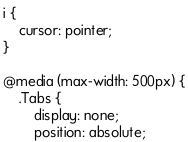Convert code to text. <code><loc_0><loc_0><loc_500><loc_500><_CSS_>
i {
    cursor: pointer;
}

@media (max-width: 500px) {
    .Tabs {
        display: none;
        position: absolute;</code> 